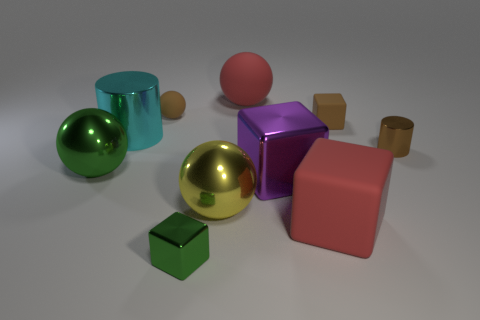Subtract all red rubber balls. How many balls are left? 3 Subtract 1 spheres. How many spheres are left? 3 Subtract all cubes. How many objects are left? 6 Subtract 1 brown cylinders. How many objects are left? 9 Subtract all cyan balls. Subtract all gray cylinders. How many balls are left? 4 Subtract all tiny blue matte balls. Subtract all large red rubber balls. How many objects are left? 9 Add 1 big red objects. How many big red objects are left? 3 Add 6 large green objects. How many large green objects exist? 7 